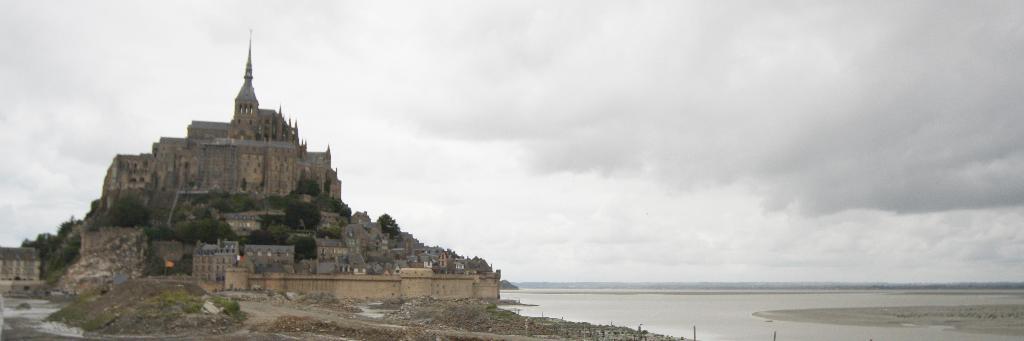How would you summarize this image in a sentence or two? On the left side of the image we can see the tower, buildings, trees, rocks, grass, ground, flag are present. On the right side of the image there is a water. At the top of the image clouds are present in the sky. 